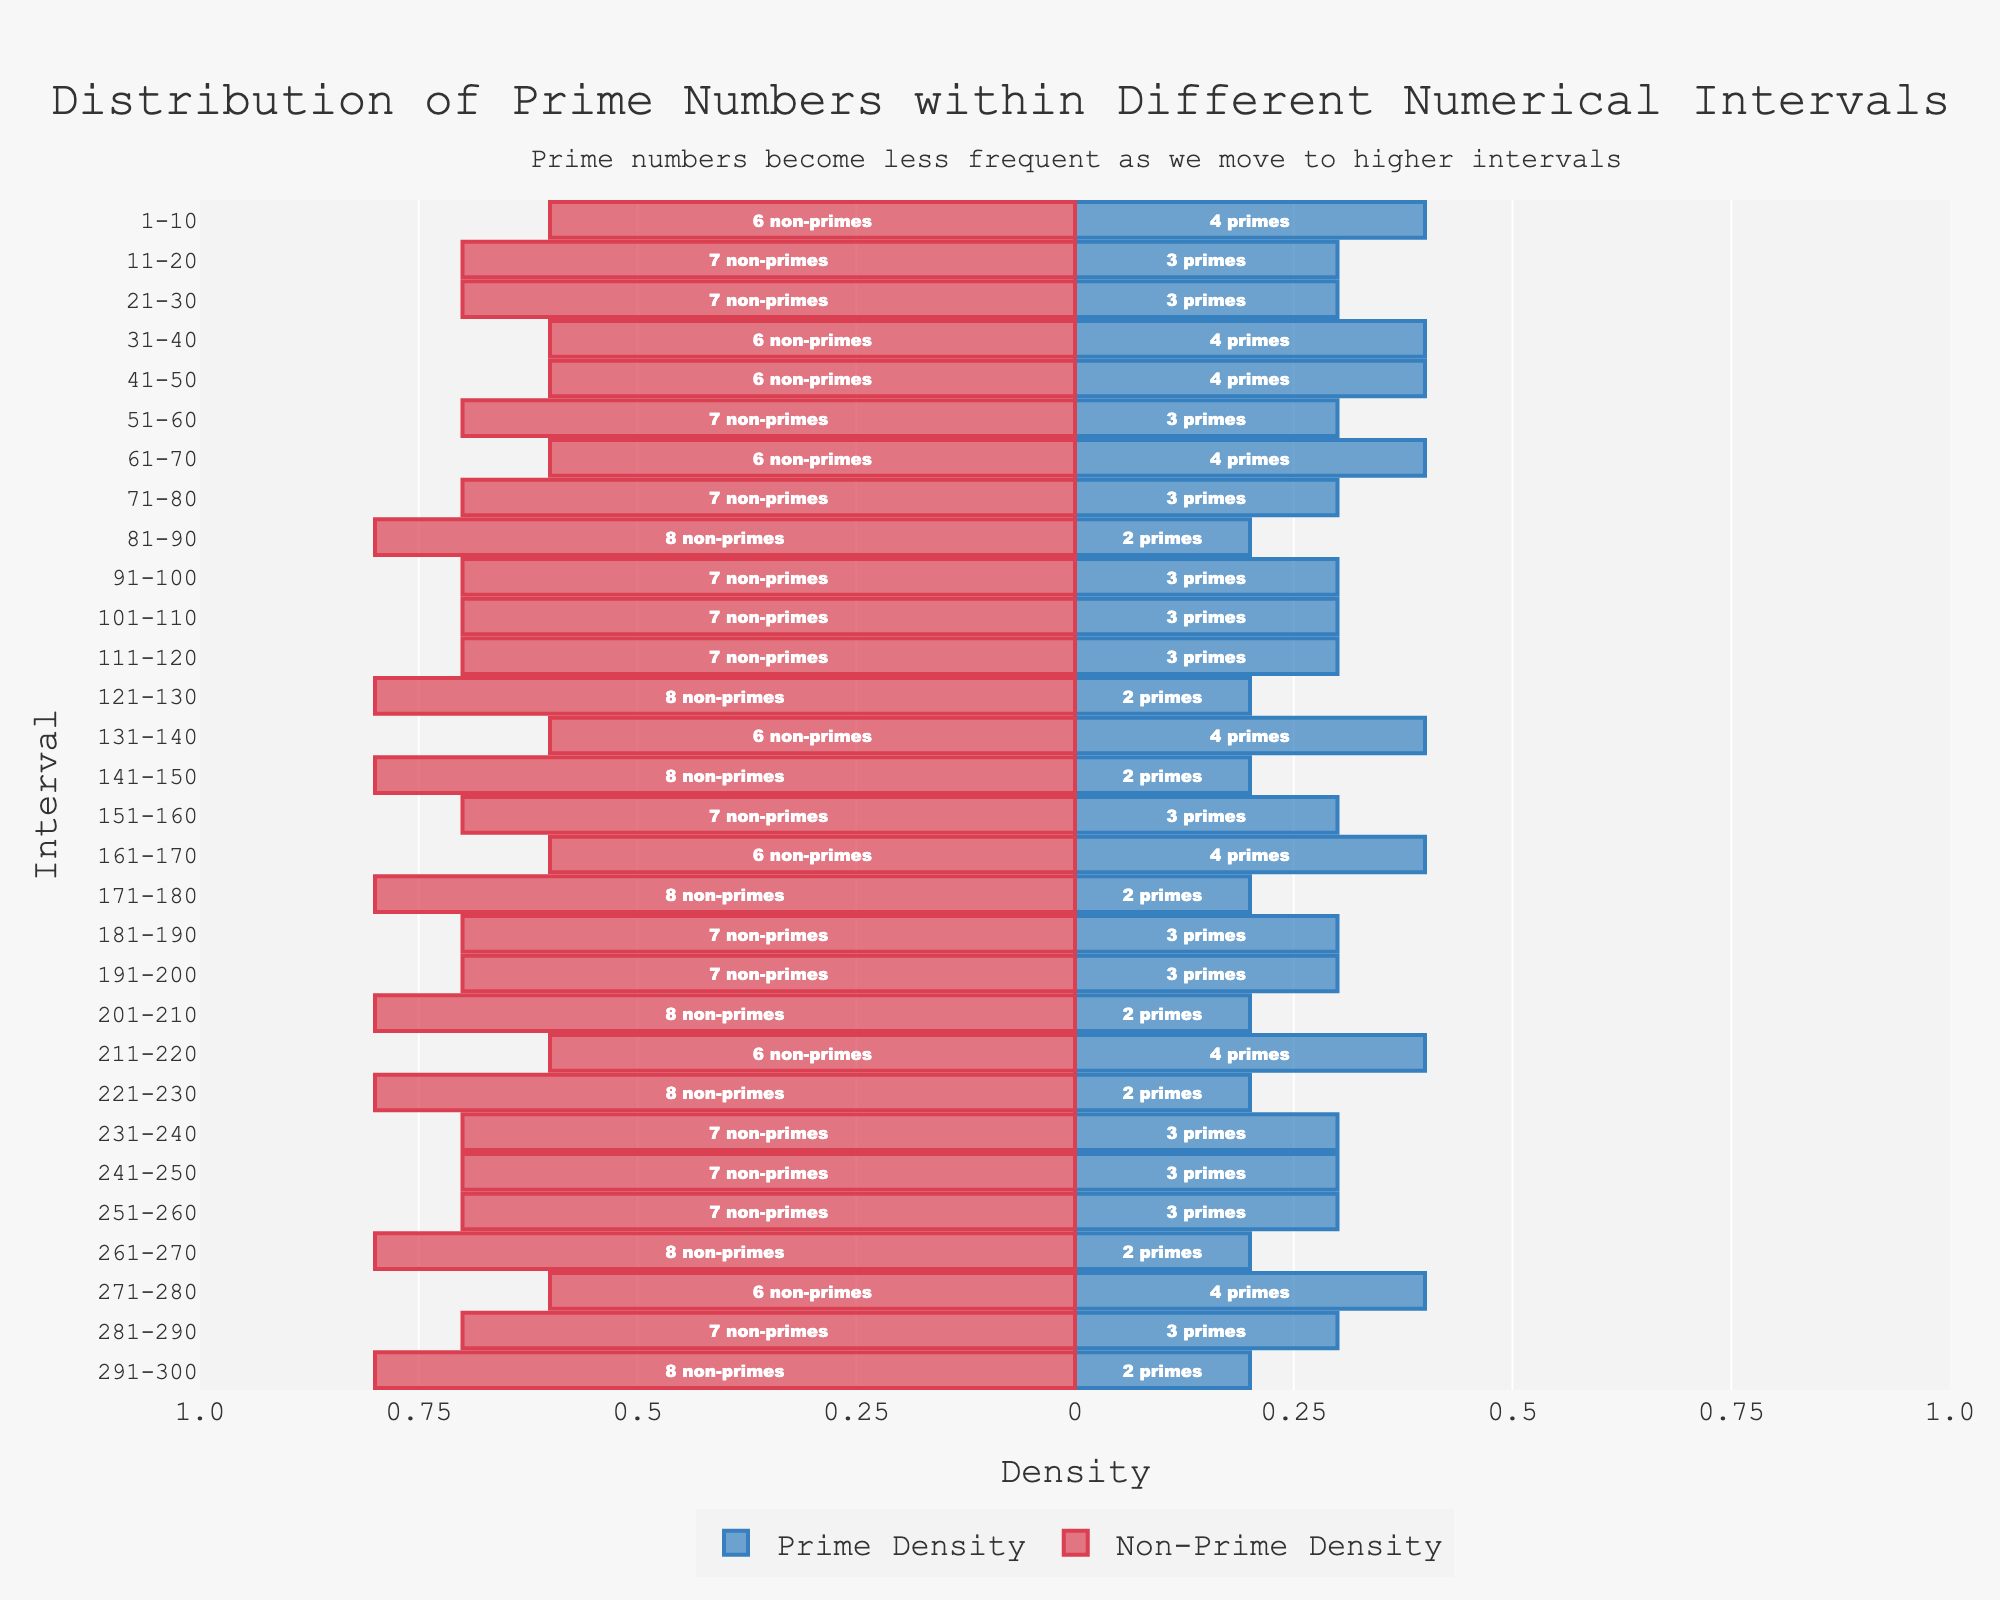What is the total number of intervals where the prime density is 0.4? We can identify the intervals with a prime density of 0.4 by looking at the lengths of the blue bars. These intervals are 1-10, 31-40, 41-50, 61-70, 131-140, 161-170, 211-220, and 271-280. There are 8 such intervals.
Answer: 8 Which interval has the lowest prime density? The interval with the shortest blue bar represents the lowest prime density. Here, the intervals with a prime density of 0.2 are 81-90, 121-130, 141-150, 171-180, 201-210, 221-230, 261-270, and 291-300.
Answer: 81-90, 121-130, 141-150, 171-180, 201-210, 221-230, 261-270, 291-300 What is the difference in the number of primes between the interval 1-10 and 81-90? In the interval 1-10, there are 4 primes indicated by the text on the blue bar. In the interval 81-90, there are 2 primes. The difference is 4 - 2 = 2.
Answer: 2 What is the sum of the prime counts in the intervals 131-140 and 151-160? The prime count in 131-140 is 4, and in 151-160, it is 3. The sum is 4 + 3 = 7.
Answer: 7 In which interval is the prime density equal to 0.3 and the total non-primes are 7? A prime density of 0.3 means checking blue bars of this length. The non-primes number indicated on the red bar must be 7. The intervals with these specific values are 11-20, 21-30, 51-60, 71-80, 91-100, 101-110, 111-120, 181-190, 191-200, 231-240, 241-250, and 251-260.
Answer: 11-20, 21-30, 51-60, 71-80, 91-100, 101-110, 111-120, 181-190, 191-200, 231-240, 241-250, 251-260 Compare the prime densities of the intervals 31-40 and 51-60. Which one is higher? The length of the blue bar for interval 31-40 is 0.4, while for interval 51-60, it is 0.3. Therefore, the prime density is higher for interval 31-40.
Answer: 31-40 How many intervals have an equal number of primes and non-primes? A bar is balanced when both prime and non-prime densities add up to equal lengths. Since each interval here has 10 numbers, no interval will have an equal number of primes and non-primes with the given densities.
Answer: 0 